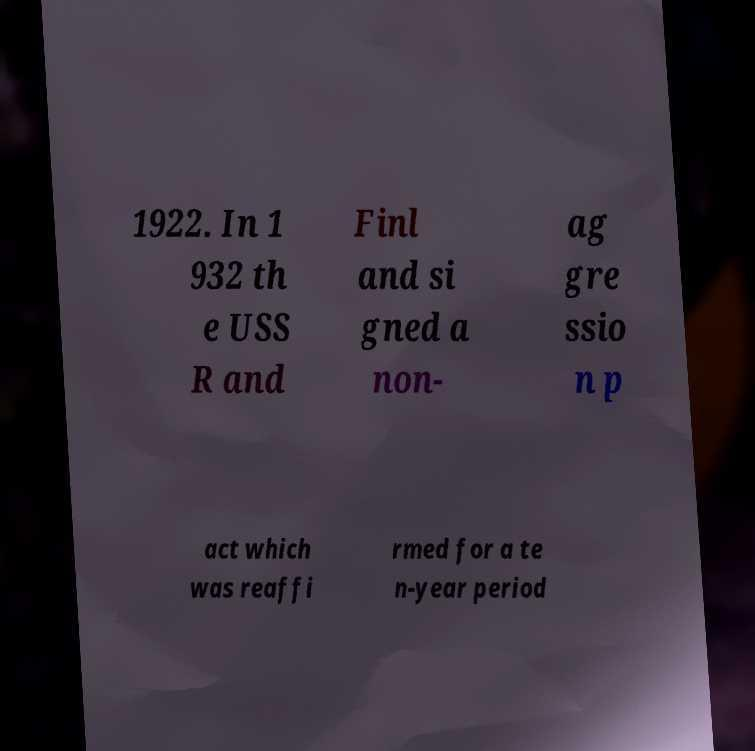I need the written content from this picture converted into text. Can you do that? 1922. In 1 932 th e USS R and Finl and si gned a non- ag gre ssio n p act which was reaffi rmed for a te n-year period 